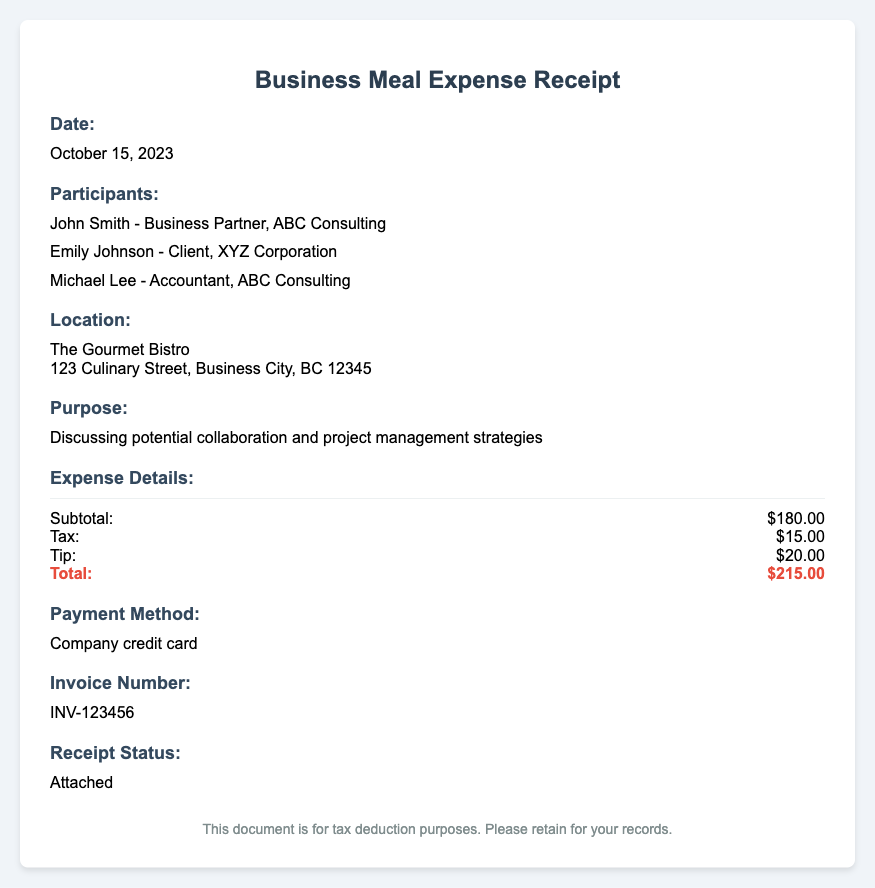what is the date of the business meal? The date of the business meal is provided in a specific section, which states "October 15, 2023."
Answer: October 15, 2023 who were the participants in the meal? The participants are listed under a specific section, detailing their names and affiliations.
Answer: John Smith, Emily Johnson, Michael Lee what is the purpose of the meal? The purpose of the meal is explicitly stated in a section, describing the discussions that took place.
Answer: Discussing potential collaboration and project management strategies where did the meal take place? The location of the meal is specified in a section with an address.
Answer: The Gourmet Bistro, 123 Culinary Street, Business City, BC 12345 what was the total amount spent? The total amount is highlighted in the expense details section, providing the final cost incurred for the meal.
Answer: $215.00 how was the meal paid for? The payment method is mentioned in a section that describes the means of payment used for this expense.
Answer: Company credit card what is the invoice number? The invoice number is provided for documentation purposes, found in a specific section of the receipt.
Answer: INV-123456 what is the receipt status? The status of the receipt is outlined in a section that indicates whether it is attached or not.
Answer: Attached 